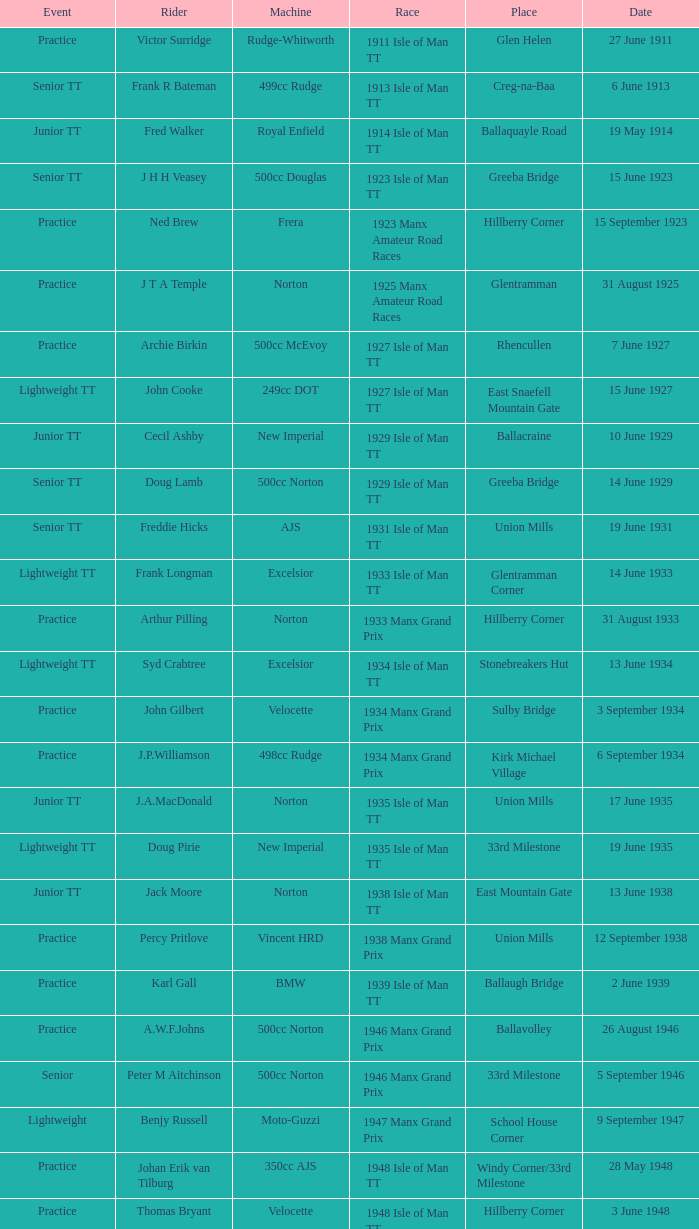What machine did Kenneth E. Herbert ride? 499cc Norton. 